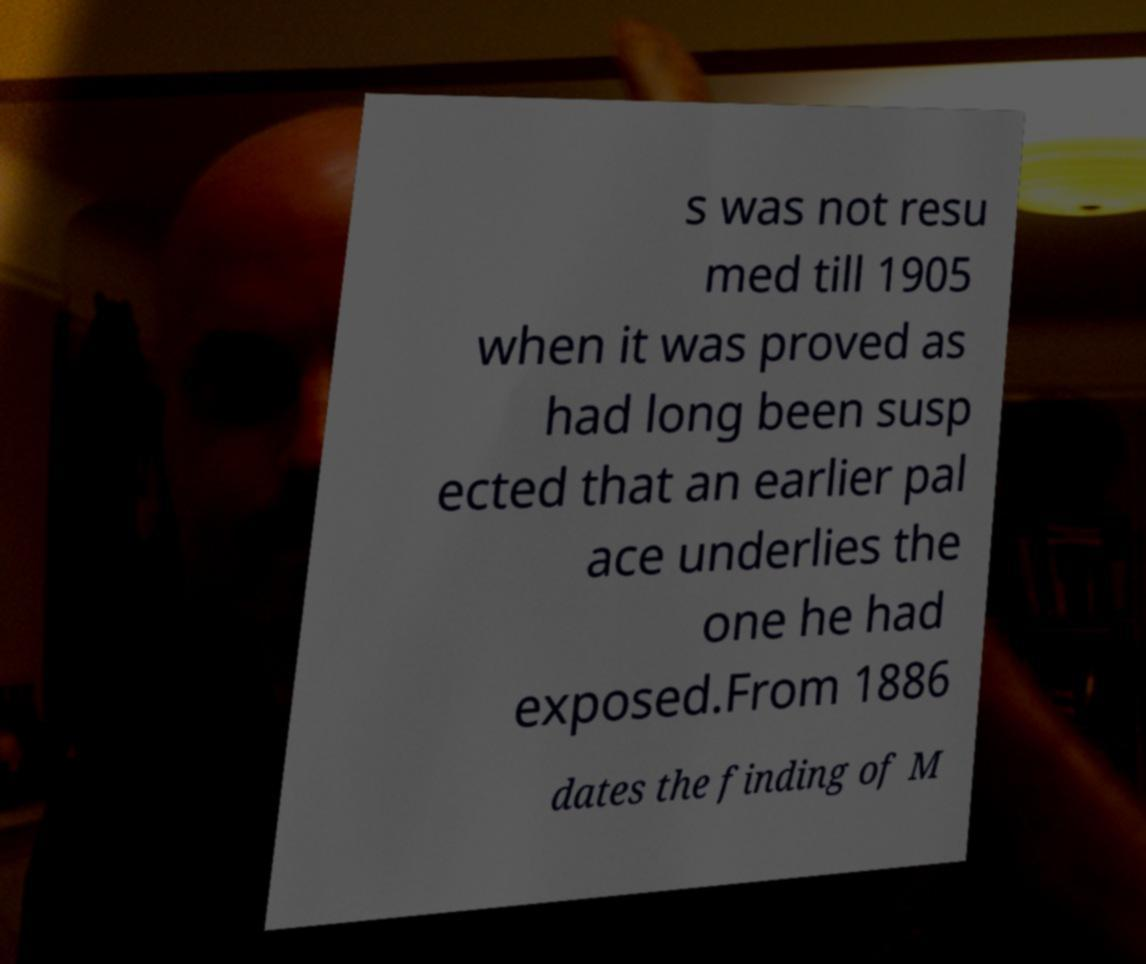Please identify and transcribe the text found in this image. s was not resu med till 1905 when it was proved as had long been susp ected that an earlier pal ace underlies the one he had exposed.From 1886 dates the finding of M 